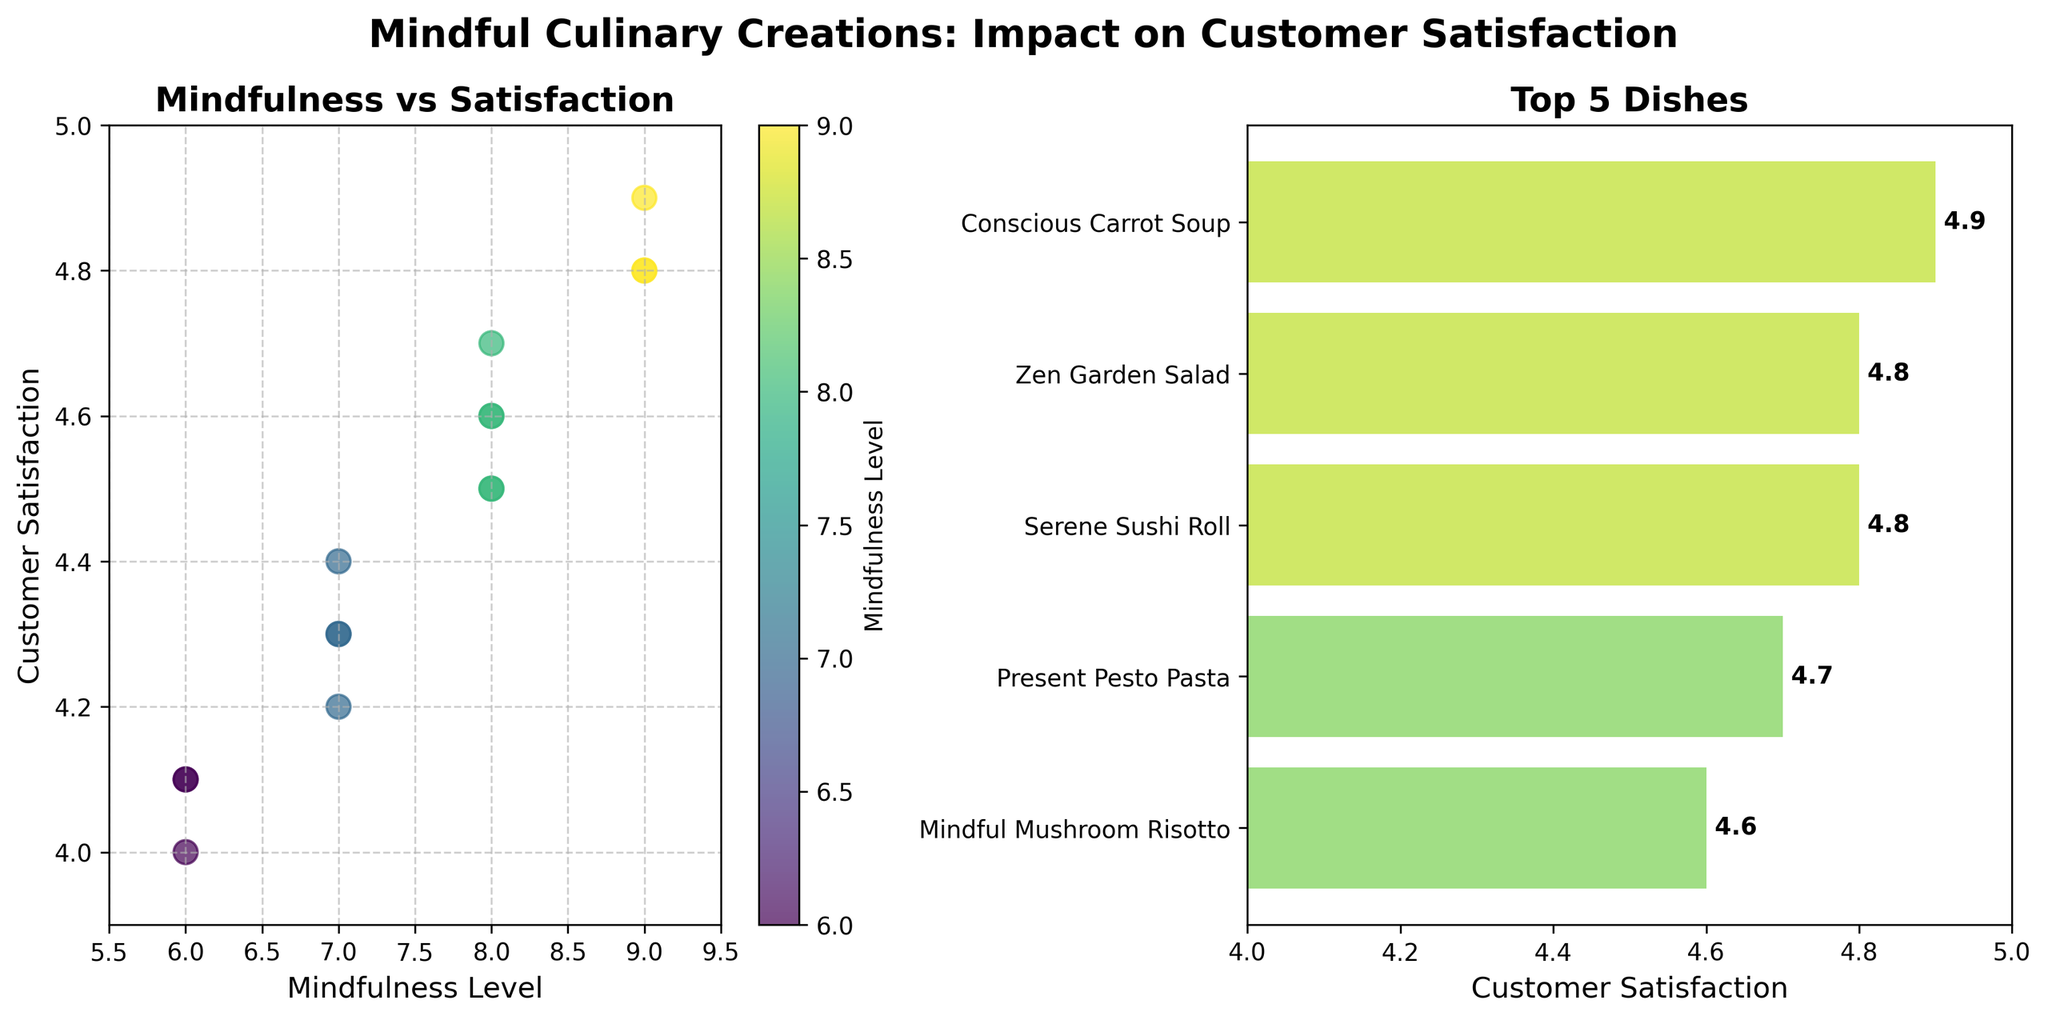What's the title of the figure? The title of the figure is written at the top and describes the overall theme or purpose of the plots.
Answer: Mindful Culinary Creations: Impact on Customer Satisfaction What does the x-axis represent in the scatter plot? The x-axis label at the bottom of the scatter plot indicates what the values along the x-axis represent.
Answer: Mindfulness Level Which dish has the highest customer satisfaction? To find the dish with the highest satisfaction, look at the top of the bars in the bar chart.
Answer: Conscious Carrot Soup What is the range of customer satisfaction ratings shown in the scatter plot? Look at the y-axis limits on the scatter plot to find the range of satisfaction ratings.
Answer: 3.9 to 5.0 How many dishes have a mindfulness level of 8? Count the number of points in the scatter plot that are aligned with the value 8 on the x-axis.
Answer: 5 Which dish has a higher customer satisfaction: Focused Fettuccine Alfredo or Breathing Bruschetta? Compare the customer satisfaction values of the two dishes shown in the scatter plot or bar chart.
Answer: Breathing Bruschetta Which dish has the highest mindfulness level among the top 5 dishes by customer satisfaction? Look at the mindfulness levels of the dishes in the bar chart and identify the highest one.
Answer: Conscious Carrot Soup What's the average customer satisfaction for dishes with a mindfulness level of 9? Identify the dishes with a mindfulness level of 9 in the scatter plot and compute their average satisfaction.
Answer: 4.83 How does customer satisfaction change with increasing mindfulness levels? Observe the general trend of the points in the scatter plot from left to right to understand the pattern.
Answer: Increases Which dish appears at the lowest position on the top 5 bar chart? Identify the dish at the bottom of the bar chart.
Answer: Grounded Grilled Salmon 